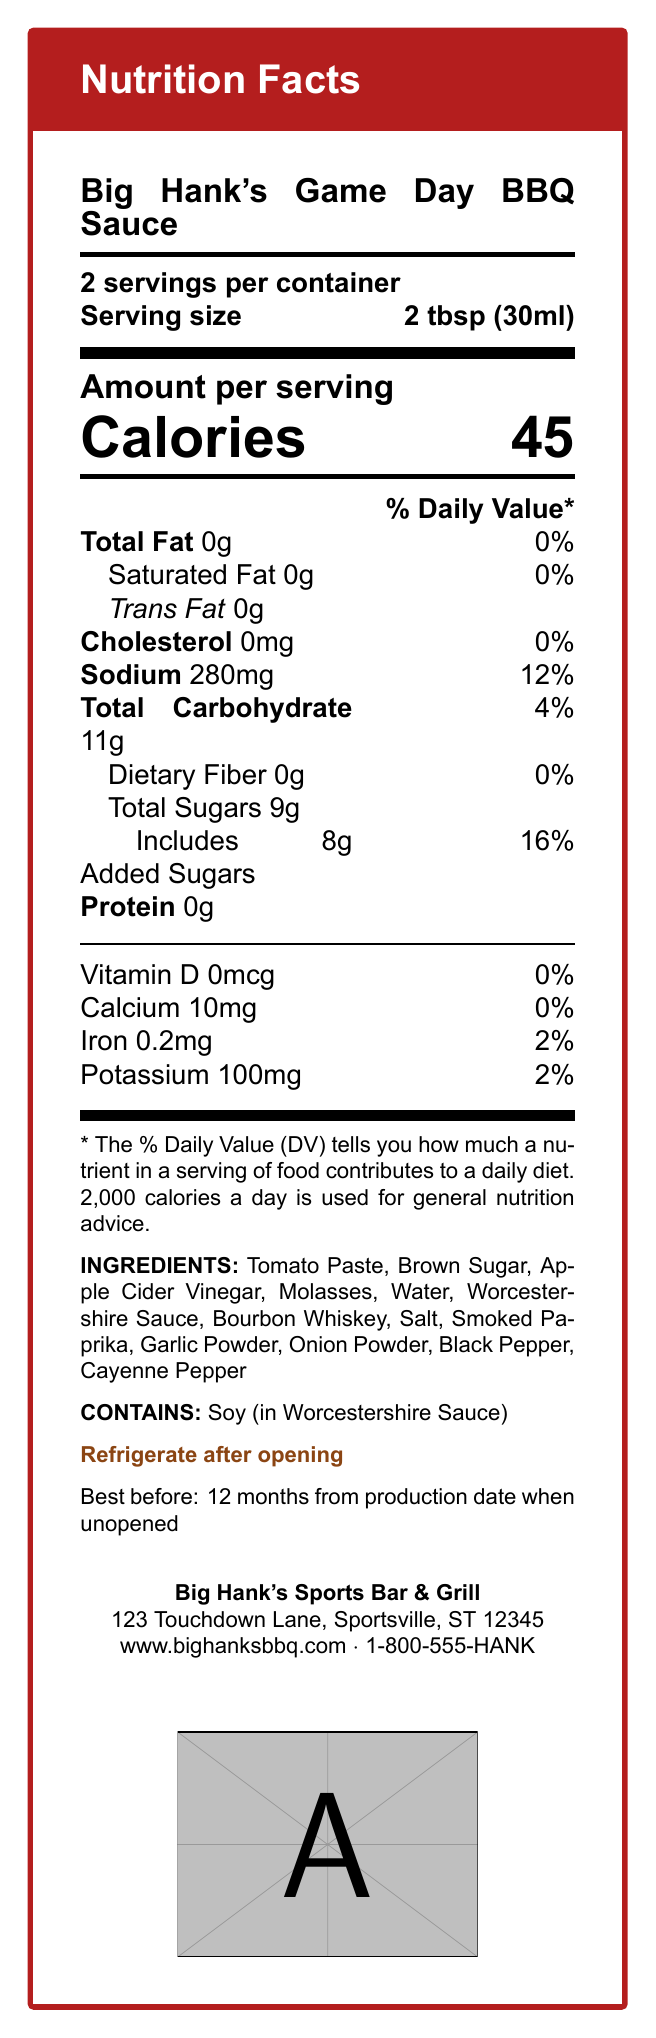what is the serving size? The document states the serving size is 2 tbsp (30ml).
Answer: 2 tbsp (30ml) How many calories are there per serving? The document specifies there are 45 calories in each serving.
Answer: 45 calories How much sodium does one serving of the BBQ sauce contain? According to the document, one serving contains 280mg of sodium.
Answer: 280mg What is the daily value percentage of added sugars in one serving? The document shows that the added sugars daily value percentage is 16%.
Answer: 16% List three main ingredients in the BBQ sauce The ingredient list provided in the document starts with Tomato Paste, Brown Sugar, and Apple Cider Vinegar.
Answer: Tomato Paste, Brown Sugar, Apple Cider Vinegar How many servings are there per container? A. 14 B. 16 C. 18 D. 20 The document specifies that there are 16 servings per container.
Answer: B What is the total carbohydrate content for one serving? A. 9g B. 10g C. 11g D. 12g The document lists the total carbohydrate content as 11g per serving.
Answer: C Does the BBQ sauce contain any dietary fiber? Yes/No The document clearly states the dietary fiber content is 0g per serving.
Answer: No Summarize the main nutritional information provided for Big Hank's Game Day BBQ Sauce This summary includes the core nutritional information highlighted in the document, covering calories, serving size, servings per container, and the main nutrient values.
Answer: Big Hank's Game Day BBQ Sauce has 45 calories per 2 tbsp (30ml) serving, with 16 servings per container. The sauce contains 0g total fat, 0mg cholesterol, 280mg sodium, 11g total carbohydrates, 9g total sugars (including 8g added sugars), and 0g protein. What is the customer service phone number for Big Hank's BBQ Sauce? The document includes this information under the contact details section.
Answer: 1-800-555-HANK Does the BBQ sauce need to be refrigerated after opening? The document states that the sauce should be refrigerated after opening.
Answer: Yes What is the source of soy allergen in the BBQ sauce? The allergen information in the document mentions that the soy comes from Worcestershire Sauce.
Answer: Worcestershire Sauce Can the exact production date be determined from the document? The document specifies the sauce is best before 12 months from the production date but does not provide the exact production date.
Answer: Not enough information 